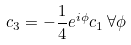Convert formula to latex. <formula><loc_0><loc_0><loc_500><loc_500>c _ { 3 } = - \frac { 1 } { 4 } e ^ { i \phi } c _ { 1 } \, \forall \phi</formula> 